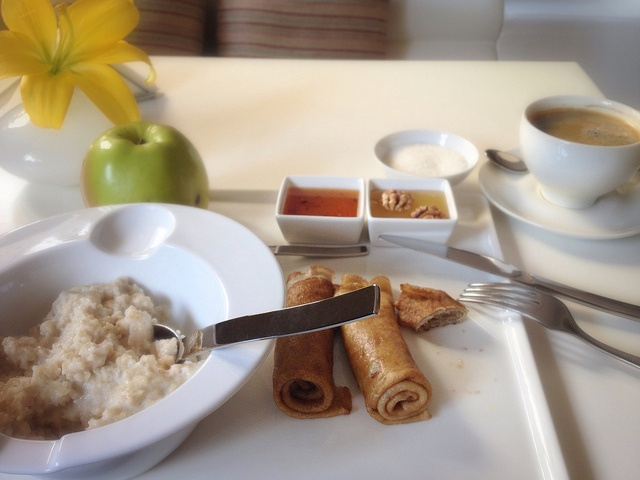Describe the objects in this image and their specific colors. I can see bowl in olive, lightgray, darkgray, and gray tones, dining table in olive, beige, tan, and darkgray tones, cup in olive, darkgray, lightgray, gray, and tan tones, bowl in olive, darkgray, lightgray, gray, and tan tones, and apple in olive tones in this image. 